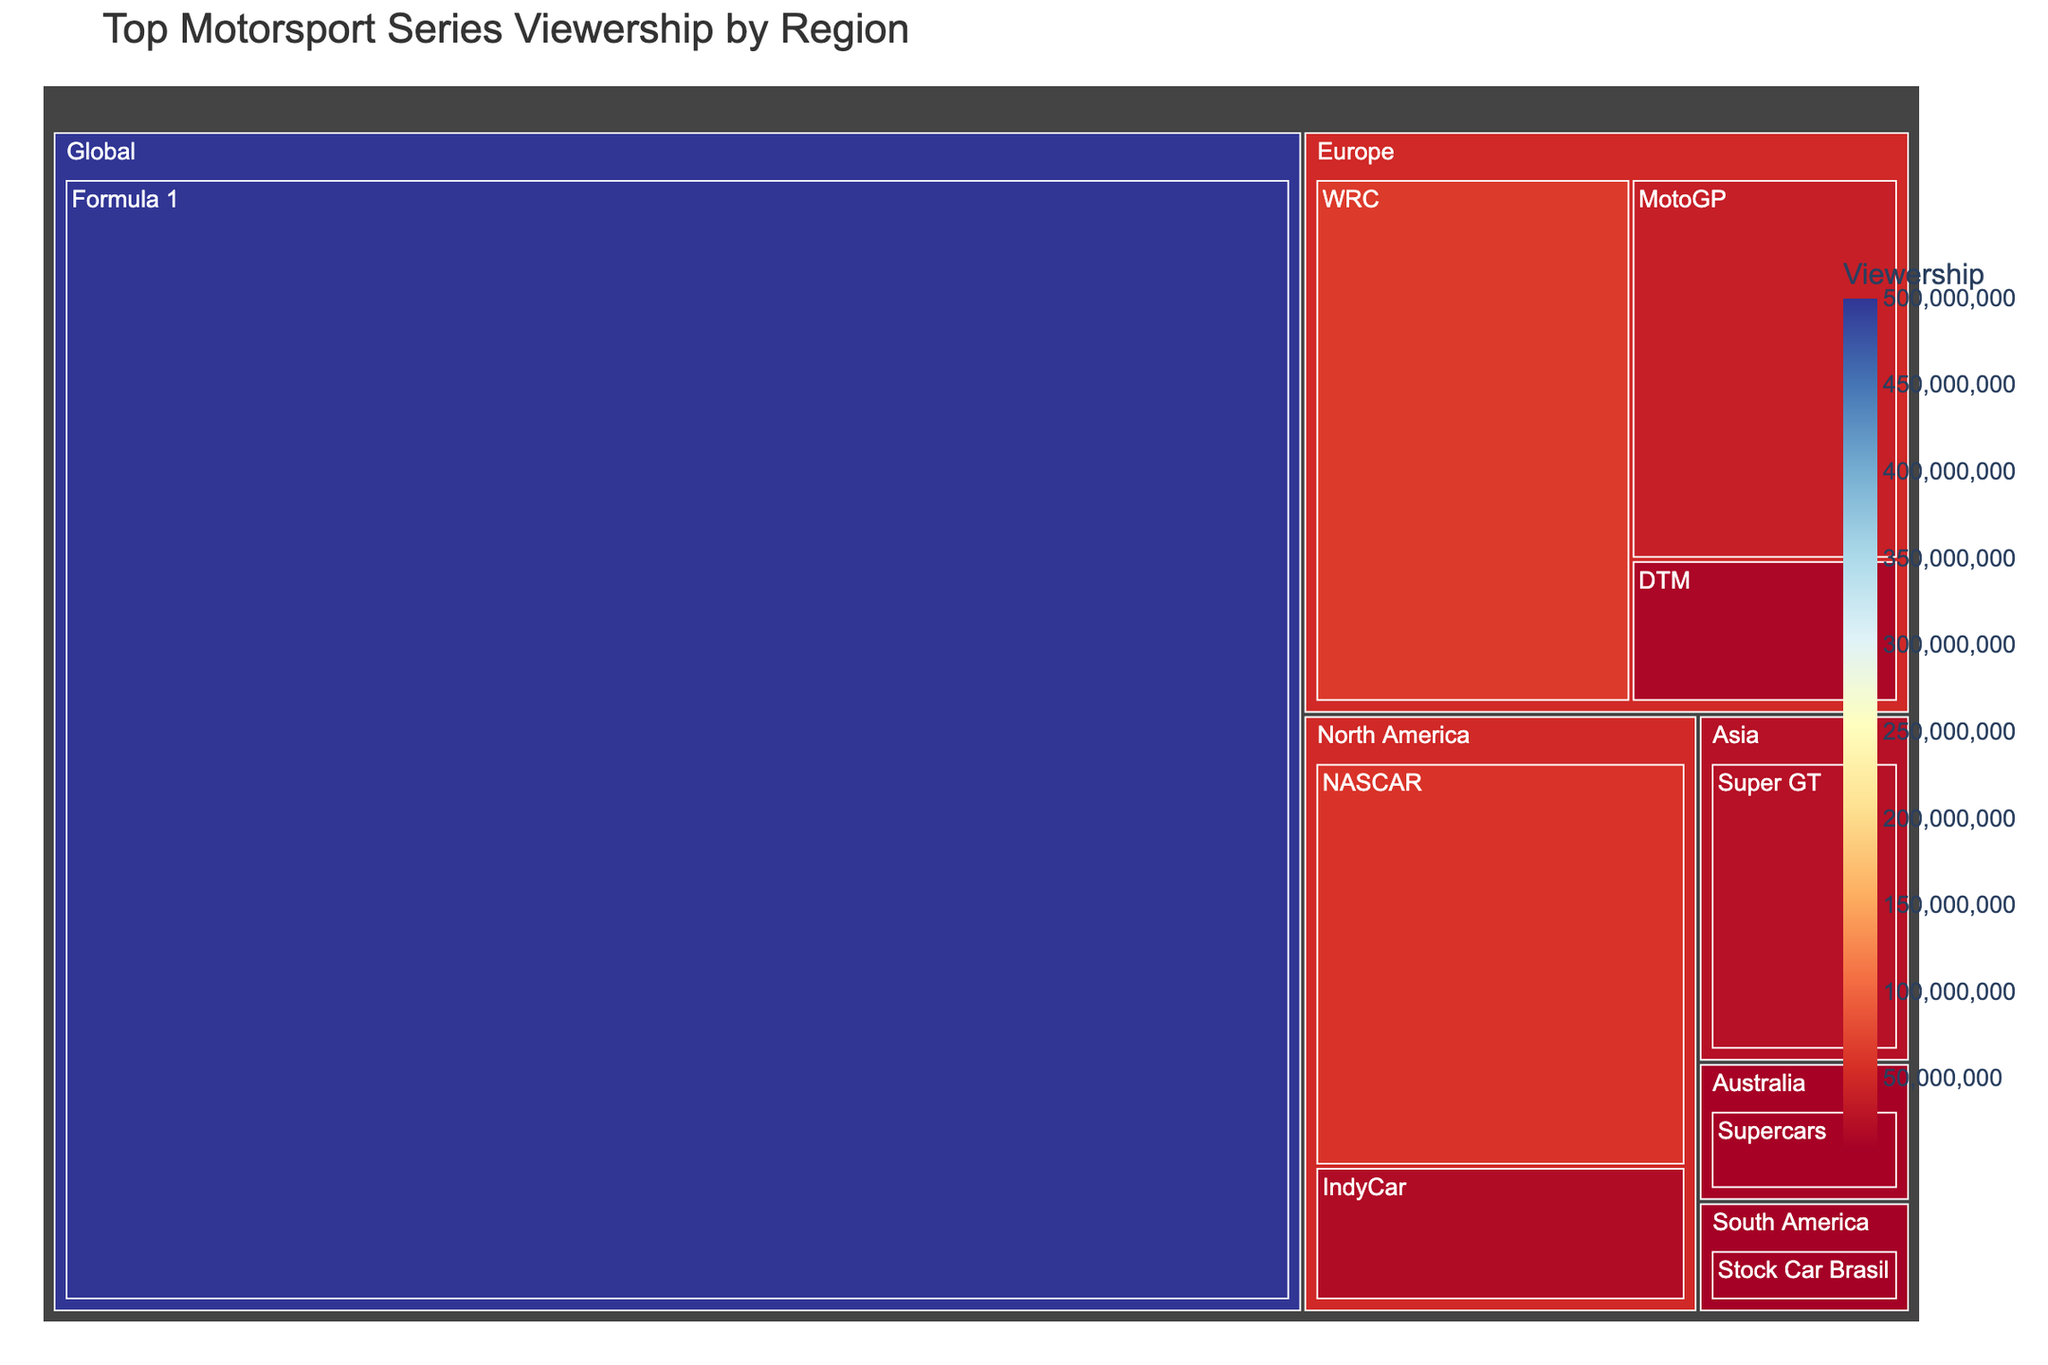What is the title of the Treemap? The title of the plot is usually shown at the top and provides an overview of the data being visualized. By reading the title, "Top Motorsport Series Viewership by Region," we understand that the plot shows the viewership numbers of various motorsport series categorized by region.
Answer: Top Motorsport Series Viewership by Region What region has the highest motorsport series viewership? The largest segment in the treemap represents the region with the highest viewership. Observing the Treemap, the "Global" section is the largest, indicating that it has the highest viewership.
Answer: Global Which motorsport series has the highest viewership overall? The largest single rectangle in the Treemap will indicate the motorsport series with the highest viewership. In this case, the rectangle labeled "Formula 1" is the largest, signifying it has the highest overall viewership.
Answer: Formula 1 What is the total viewership for motorsports in North America? To get the total, we sum up the viewership numbers for all North American series. These are NASCAR with 60,000,000 and IndyCar with 20,000,000. Summing these gives us the total viewership. 60,000,000 + 20,000,000 = 80,000,000.
Answer: 80,000,000 How does the viewership of MotoGP compare to that of WRC in Europe? We compare the viewership numbers of MotoGP and WRC, both part of the European segment. WRC has 65,000,000 and MotoGP has 40,000,000 viewers. WRC has a higher viewership than MotoGP.
Answer: WRC is higher What is the combined viewership of all non-European motorsport series? We add the viewership numbers for all series outside of Europe: Formula 1 (500,000,000), NASCAR (60,000,000), IndyCar (20,000,000), Super GT (25,000,000), Supercars (10,000,000), and Stock Car Brasil (8,000,000). 500,000,000 + 60,000,000 + 20,000,000 + 25,000,000 + 10,000,000 + 8,000,000 = 623,000,000.
Answer: 623,000,000 Which region has the smallest viewership for motorsports and which series does it belong to? Looking for the smallest segment in the Treemap, we find "Stock Car Brasil" in the South America region with 8,000,000 viewers, making it the smallest viewership by region and series.
Answer: South America, Stock Car Brasil What fraction of the global viewership is accounted for by Formula 1 compared to the total viewership of Europe? To calculate the fraction, we take the viewership of Formula 1 (500,000,000) and compare it to the total viewership of Europe. Summing Europe's series: WRC (65,000,000), MotoGP (40,000,000), and DTM (15,000,000) gives us 120,000,000. The fraction is 500,000,000 / 120,000,000 ≈ 4.17.
Answer: About 4.17 times What's the difference in viewership between the WRC and the Super GT series? By subtracting the viewership of the Super GT series (25,000,000) from the WRC series (65,000,000), we get the difference. 65,000,000 - 25,000,000 = 40,000,000.
Answer: 40,000,000 Which non-global series has the highest viewership, and in which region is it located? Among the non-global series, the largest rectangle represents WRC in the Europe region with 65,000,000 viewers, making it the highest.
Answer: WRC, Europe 